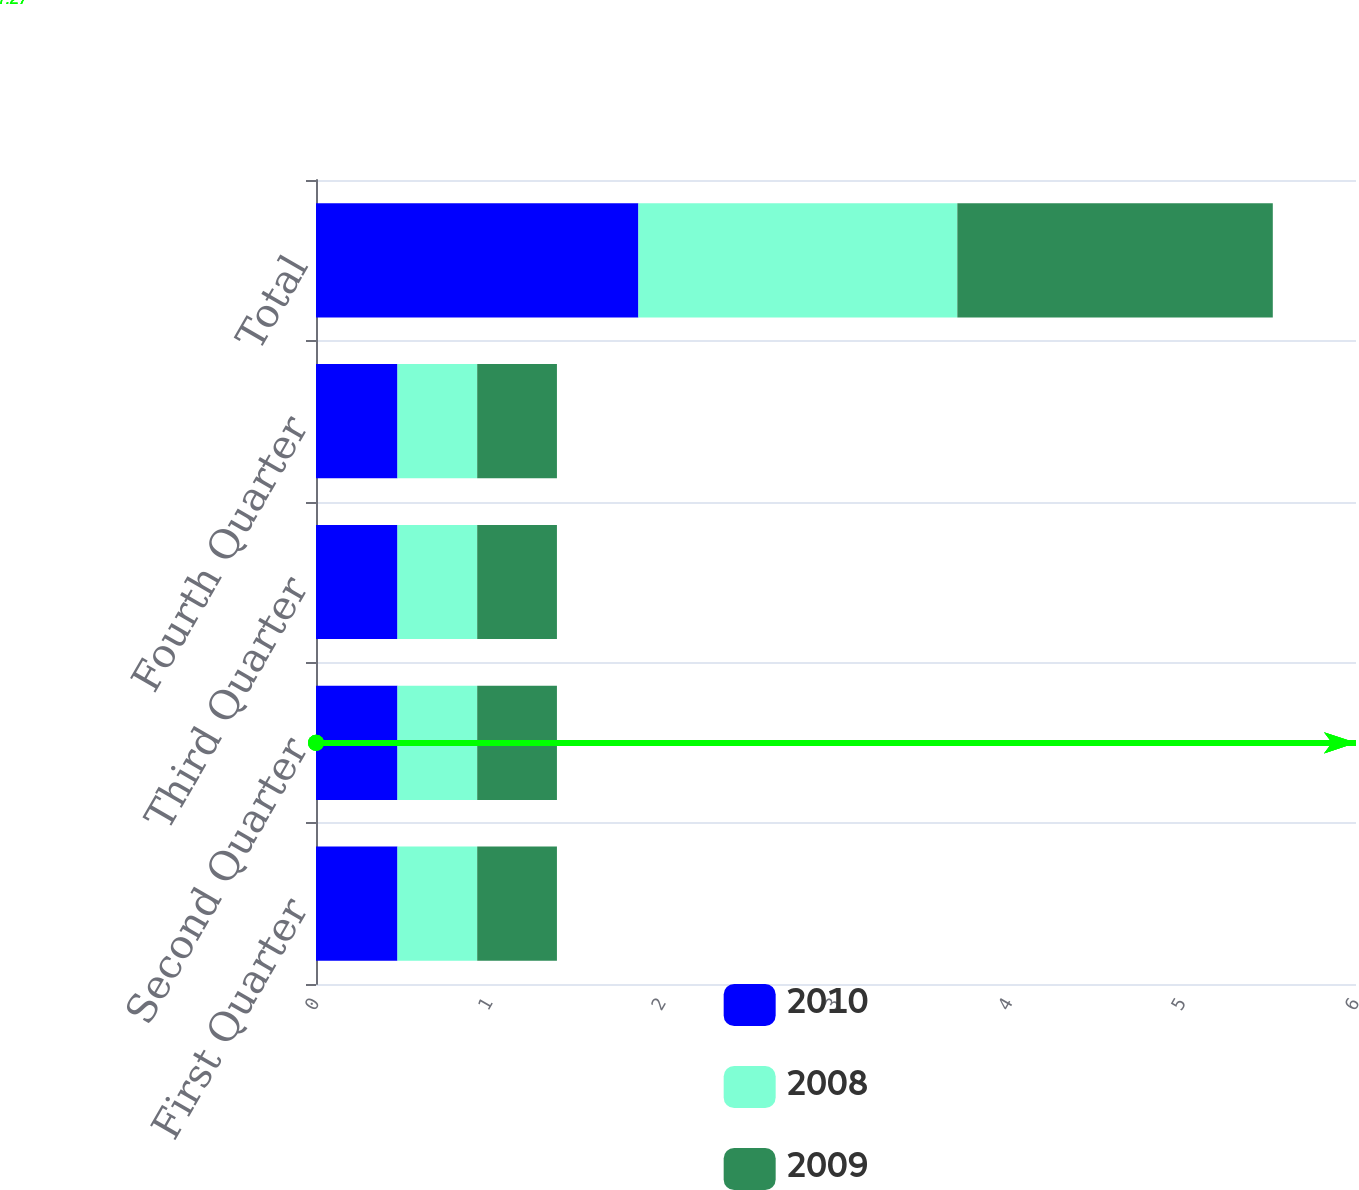Convert chart. <chart><loc_0><loc_0><loc_500><loc_500><stacked_bar_chart><ecel><fcel>First Quarter<fcel>Second Quarter<fcel>Third Quarter<fcel>Fourth Quarter<fcel>Total<nl><fcel>2010<fcel>0.47<fcel>0.47<fcel>0.47<fcel>0.47<fcel>1.86<nl><fcel>2008<fcel>0.46<fcel>0.46<fcel>0.46<fcel>0.46<fcel>1.84<nl><fcel>2009<fcel>0.46<fcel>0.46<fcel>0.46<fcel>0.46<fcel>1.82<nl></chart> 